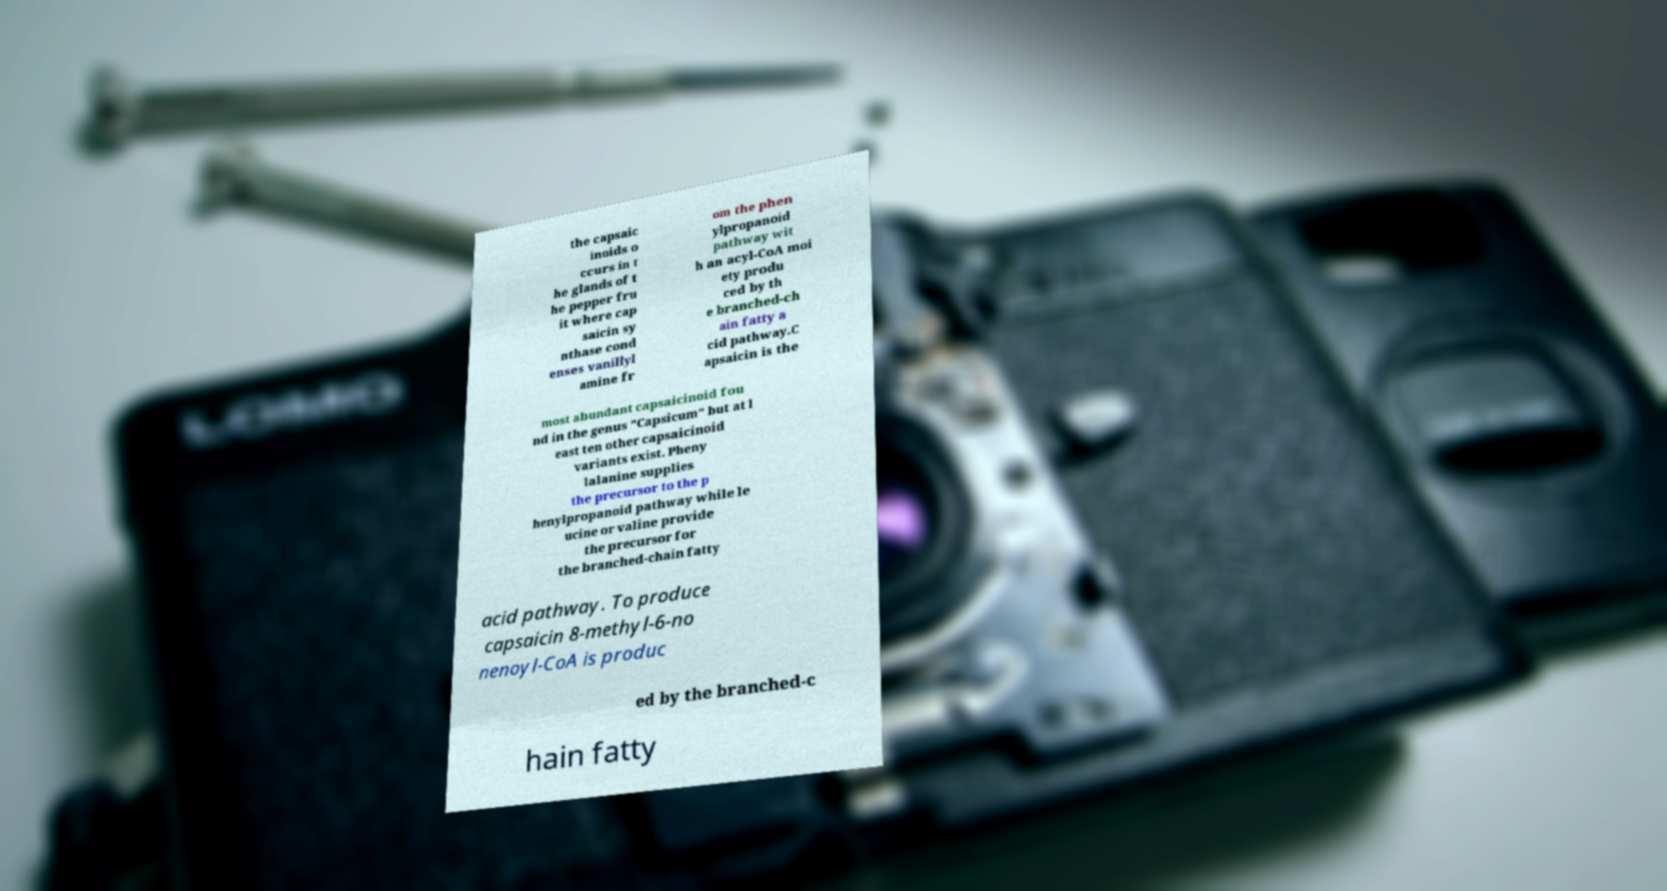Please identify and transcribe the text found in this image. the capsaic inoids o ccurs in t he glands of t he pepper fru it where cap saicin sy nthase cond enses vanillyl amine fr om the phen ylpropanoid pathway wit h an acyl-CoA moi ety produ ced by th e branched-ch ain fatty a cid pathway.C apsaicin is the most abundant capsaicinoid fou nd in the genus "Capsicum" but at l east ten other capsaicinoid variants exist. Pheny lalanine supplies the precursor to the p henylpropanoid pathway while le ucine or valine provide the precursor for the branched-chain fatty acid pathway. To produce capsaicin 8-methyl-6-no nenoyl-CoA is produc ed by the branched-c hain fatty 